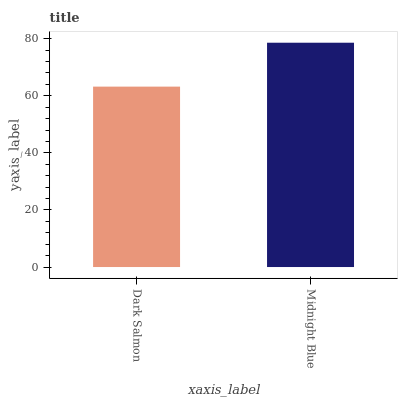Is Dark Salmon the minimum?
Answer yes or no. Yes. Is Midnight Blue the maximum?
Answer yes or no. Yes. Is Midnight Blue the minimum?
Answer yes or no. No. Is Midnight Blue greater than Dark Salmon?
Answer yes or no. Yes. Is Dark Salmon less than Midnight Blue?
Answer yes or no. Yes. Is Dark Salmon greater than Midnight Blue?
Answer yes or no. No. Is Midnight Blue less than Dark Salmon?
Answer yes or no. No. Is Midnight Blue the high median?
Answer yes or no. Yes. Is Dark Salmon the low median?
Answer yes or no. Yes. Is Dark Salmon the high median?
Answer yes or no. No. Is Midnight Blue the low median?
Answer yes or no. No. 